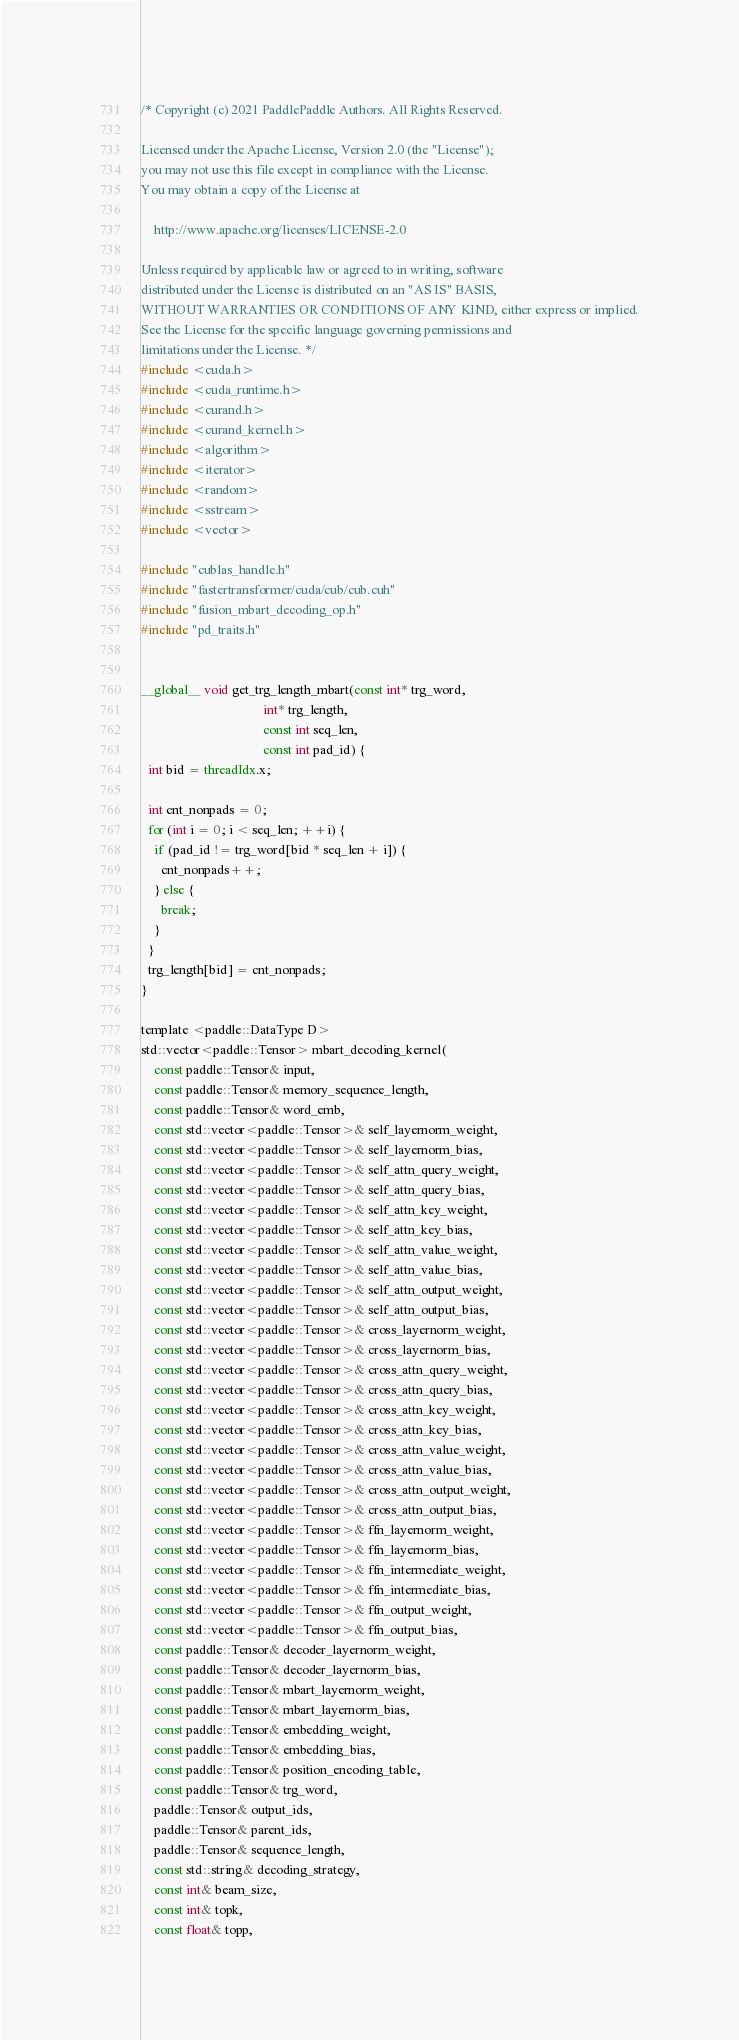Convert code to text. <code><loc_0><loc_0><loc_500><loc_500><_Cuda_>/* Copyright (c) 2021 PaddlePaddle Authors. All Rights Reserved.

Licensed under the Apache License, Version 2.0 (the "License");
you may not use this file except in compliance with the License.
You may obtain a copy of the License at

    http://www.apache.org/licenses/LICENSE-2.0

Unless required by applicable law or agreed to in writing, software
distributed under the License is distributed on an "AS IS" BASIS,
WITHOUT WARRANTIES OR CONDITIONS OF ANY KIND, either express or implied.
See the License for the specific language governing permissions and
limitations under the License. */
#include <cuda.h>
#include <cuda_runtime.h>
#include <curand.h>
#include <curand_kernel.h>
#include <algorithm>
#include <iterator>
#include <random>
#include <sstream>
#include <vector>

#include "cublas_handle.h"
#include "fastertransformer/cuda/cub/cub.cuh"
#include "fusion_mbart_decoding_op.h"
#include "pd_traits.h"


__global__ void get_trg_length_mbart(const int* trg_word,
                                     int* trg_length,
                                     const int seq_len,
                                     const int pad_id) {
  int bid = threadIdx.x;

  int cnt_nonpads = 0;
  for (int i = 0; i < seq_len; ++i) {
    if (pad_id != trg_word[bid * seq_len + i]) {
      cnt_nonpads++;
    } else {
      break;
    }
  }
  trg_length[bid] = cnt_nonpads;
}

template <paddle::DataType D>
std::vector<paddle::Tensor> mbart_decoding_kernel(
    const paddle::Tensor& input,
    const paddle::Tensor& memory_sequence_length,
    const paddle::Tensor& word_emb,
    const std::vector<paddle::Tensor>& self_layernorm_weight,
    const std::vector<paddle::Tensor>& self_layernorm_bias,
    const std::vector<paddle::Tensor>& self_attn_query_weight,
    const std::vector<paddle::Tensor>& self_attn_query_bias,
    const std::vector<paddle::Tensor>& self_attn_key_weight,
    const std::vector<paddle::Tensor>& self_attn_key_bias,
    const std::vector<paddle::Tensor>& self_attn_value_weight,
    const std::vector<paddle::Tensor>& self_attn_value_bias,
    const std::vector<paddle::Tensor>& self_attn_output_weight,
    const std::vector<paddle::Tensor>& self_attn_output_bias,
    const std::vector<paddle::Tensor>& cross_layernorm_weight,
    const std::vector<paddle::Tensor>& cross_layernorm_bias,
    const std::vector<paddle::Tensor>& cross_attn_query_weight,
    const std::vector<paddle::Tensor>& cross_attn_query_bias,
    const std::vector<paddle::Tensor>& cross_attn_key_weight,
    const std::vector<paddle::Tensor>& cross_attn_key_bias,
    const std::vector<paddle::Tensor>& cross_attn_value_weight,
    const std::vector<paddle::Tensor>& cross_attn_value_bias,
    const std::vector<paddle::Tensor>& cross_attn_output_weight,
    const std::vector<paddle::Tensor>& cross_attn_output_bias,
    const std::vector<paddle::Tensor>& ffn_layernorm_weight,
    const std::vector<paddle::Tensor>& ffn_layernorm_bias,
    const std::vector<paddle::Tensor>& ffn_intermediate_weight,
    const std::vector<paddle::Tensor>& ffn_intermediate_bias,
    const std::vector<paddle::Tensor>& ffn_output_weight,
    const std::vector<paddle::Tensor>& ffn_output_bias,
    const paddle::Tensor& decoder_layernorm_weight,
    const paddle::Tensor& decoder_layernorm_bias,
    const paddle::Tensor& mbart_layernorm_weight,
    const paddle::Tensor& mbart_layernorm_bias,
    const paddle::Tensor& embedding_weight,
    const paddle::Tensor& embedding_bias,
    const paddle::Tensor& position_encoding_table,
    const paddle::Tensor& trg_word,
    paddle::Tensor& output_ids,
    paddle::Tensor& parent_ids,
    paddle::Tensor& sequence_length,
    const std::string& decoding_strategy,
    const int& beam_size,
    const int& topk,
    const float& topp,</code> 